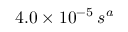<formula> <loc_0><loc_0><loc_500><loc_500>4 . 0 \times 1 0 ^ { - 5 } \, s ^ { a }</formula> 